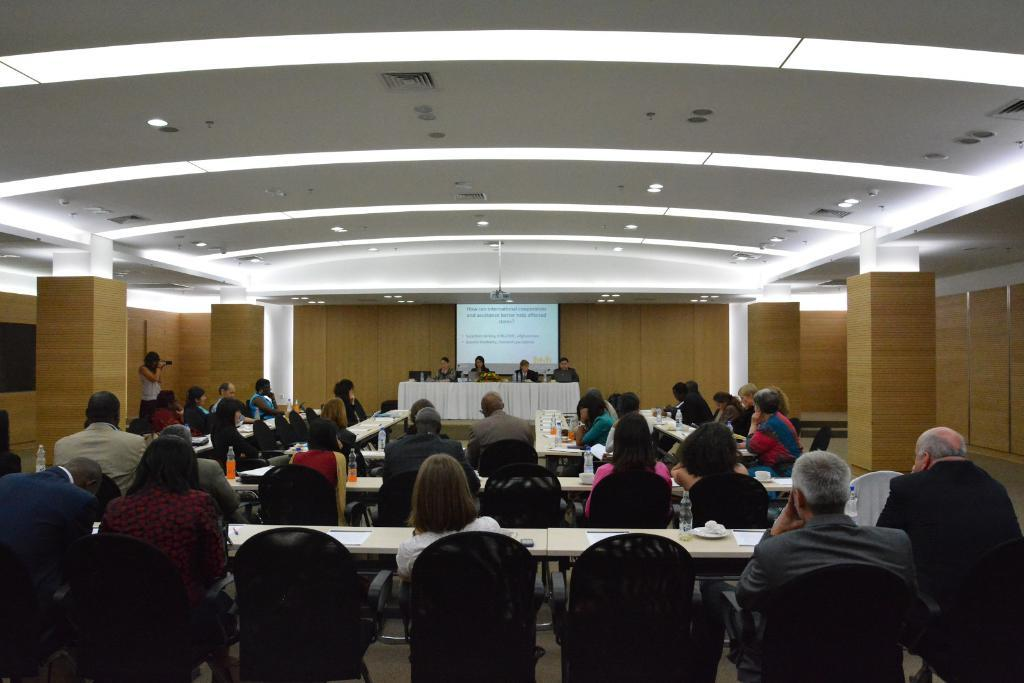What are the people in the image doing? The persons in the image are sitting on chairs. What is present in the image besides the people? There is a table in the image. What can be seen in the background of the image? There is a screen and a wall in the background of the image. What type of lighting is present in the image? There are lights in the image. What type of memory is being used by the screen in the image? There is no information about the type of memory being used by the screen in the image. What spark can be seen coming from the lights in the image? There is no spark visible coming from the lights in the image. 